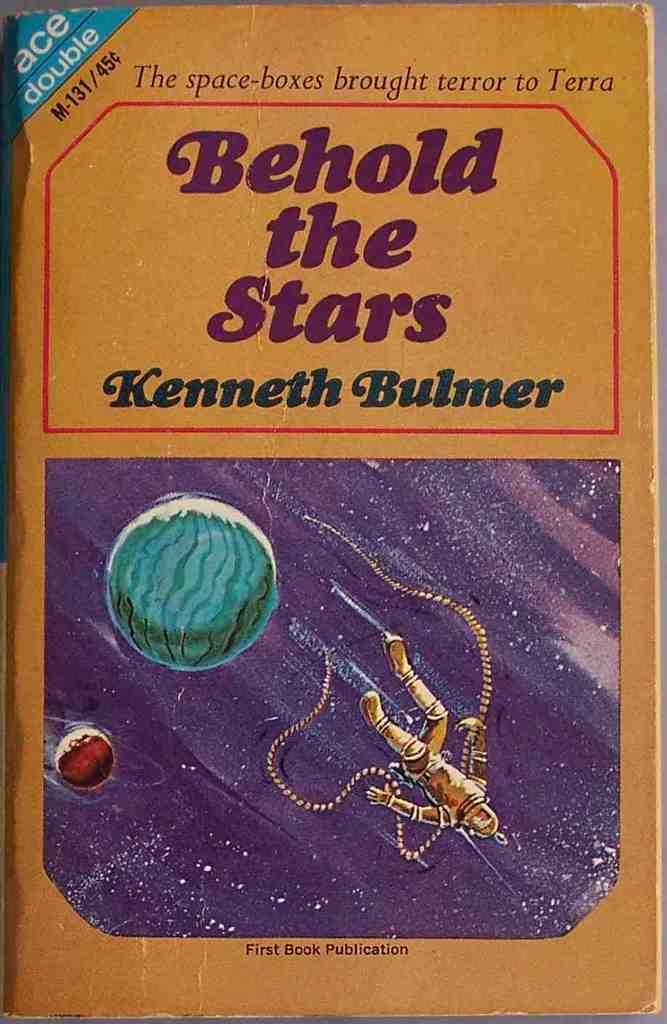Provide a one-sentence caption for the provided image. A book by Kenneth Bulmer titled Behold the Stars. 